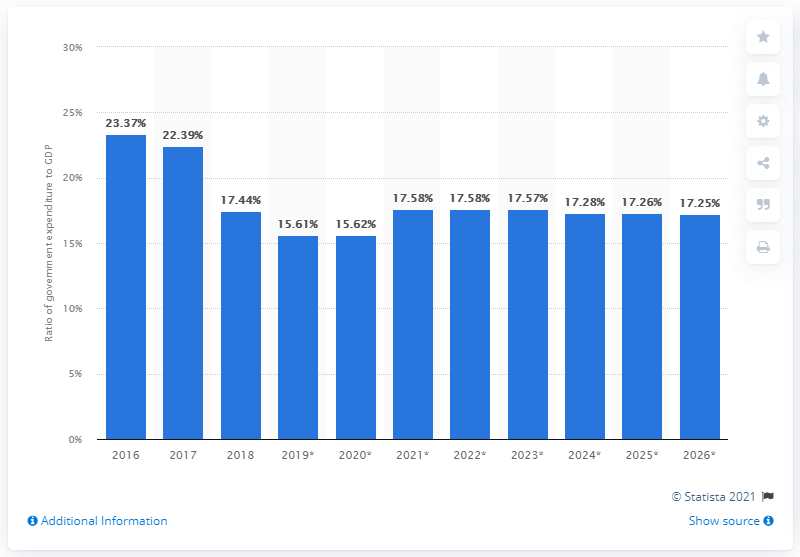Highlight a few significant elements in this photo. In 2018, government expenditure in Zimbabwe accounted for 17.28% of the country's Gross Domestic Product (GDP). In 2018, there was a significant change in the ratio of government expenditure to gross domestic product. 